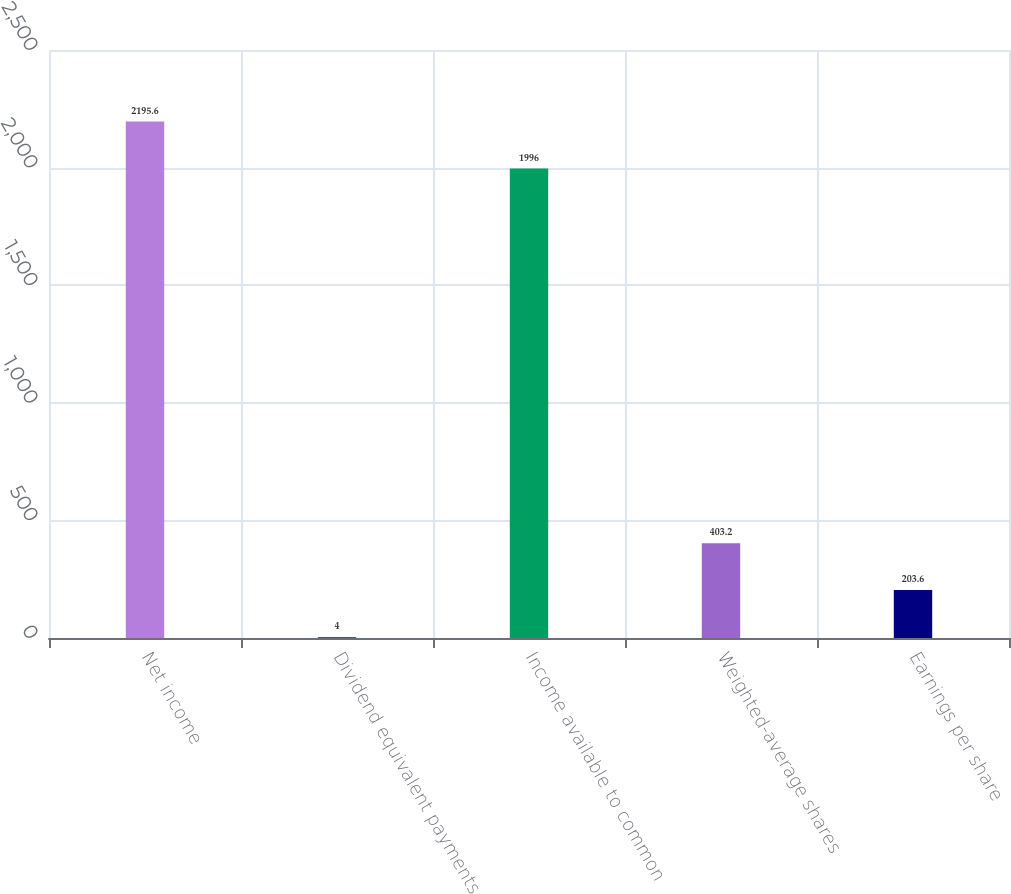Convert chart to OTSL. <chart><loc_0><loc_0><loc_500><loc_500><bar_chart><fcel>Net income<fcel>Dividend equivalent payments<fcel>Income available to common<fcel>Weighted-average shares<fcel>Earnings per share<nl><fcel>2195.6<fcel>4<fcel>1996<fcel>403.2<fcel>203.6<nl></chart> 